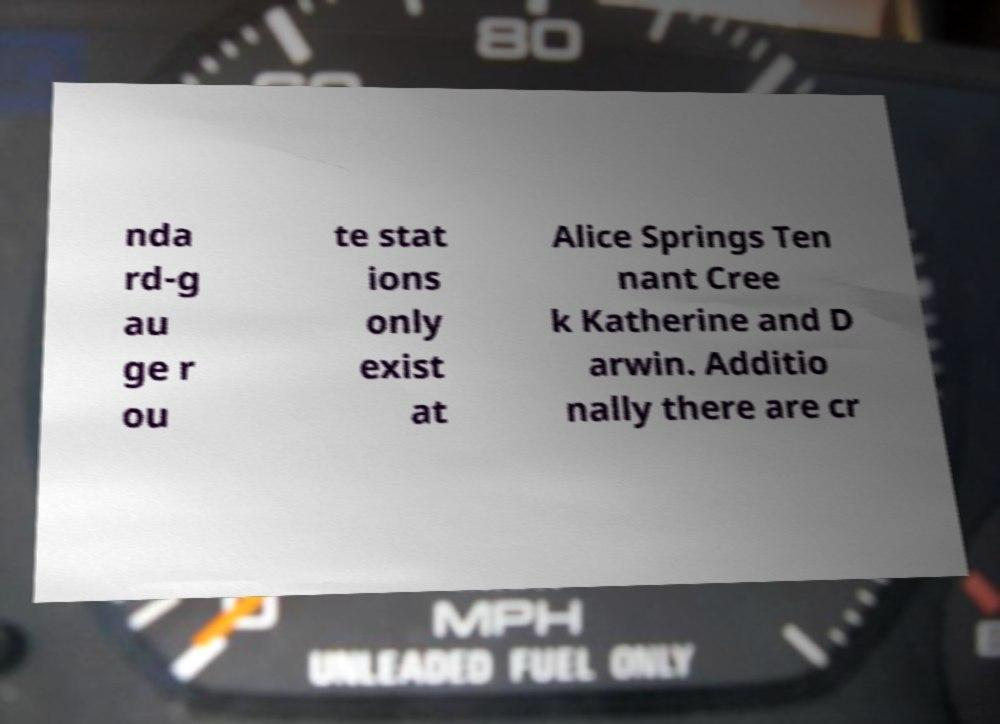Please read and relay the text visible in this image. What does it say? nda rd-g au ge r ou te stat ions only exist at Alice Springs Ten nant Cree k Katherine and D arwin. Additio nally there are cr 